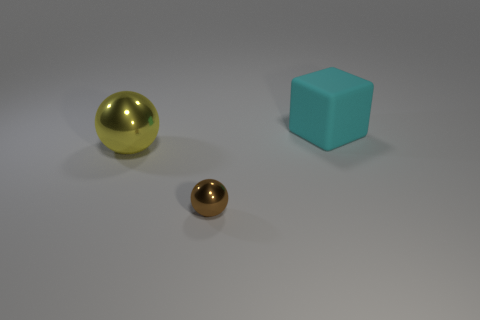What number of other objects are there of the same size as the cyan block?
Offer a terse response. 1. What number of objects are either big green metal objects or large objects in front of the big cyan block?
Provide a succinct answer. 1. Are there an equal number of large yellow shiny balls that are behind the cyan cube and metallic spheres?
Your answer should be very brief. No. Are there any metallic objects of the same color as the matte block?
Offer a very short reply. No. How many metal objects are either large blocks or tiny red cylinders?
Provide a succinct answer. 0. What number of yellow things are behind the ball left of the brown shiny ball?
Ensure brevity in your answer.  0. How many things are made of the same material as the brown sphere?
Your answer should be compact. 1. What number of big things are either brown balls or cyan things?
Make the answer very short. 1. What is the shape of the thing that is in front of the large cyan matte block and behind the small metallic sphere?
Ensure brevity in your answer.  Sphere. Is the cyan object made of the same material as the large yellow sphere?
Keep it short and to the point. No. 